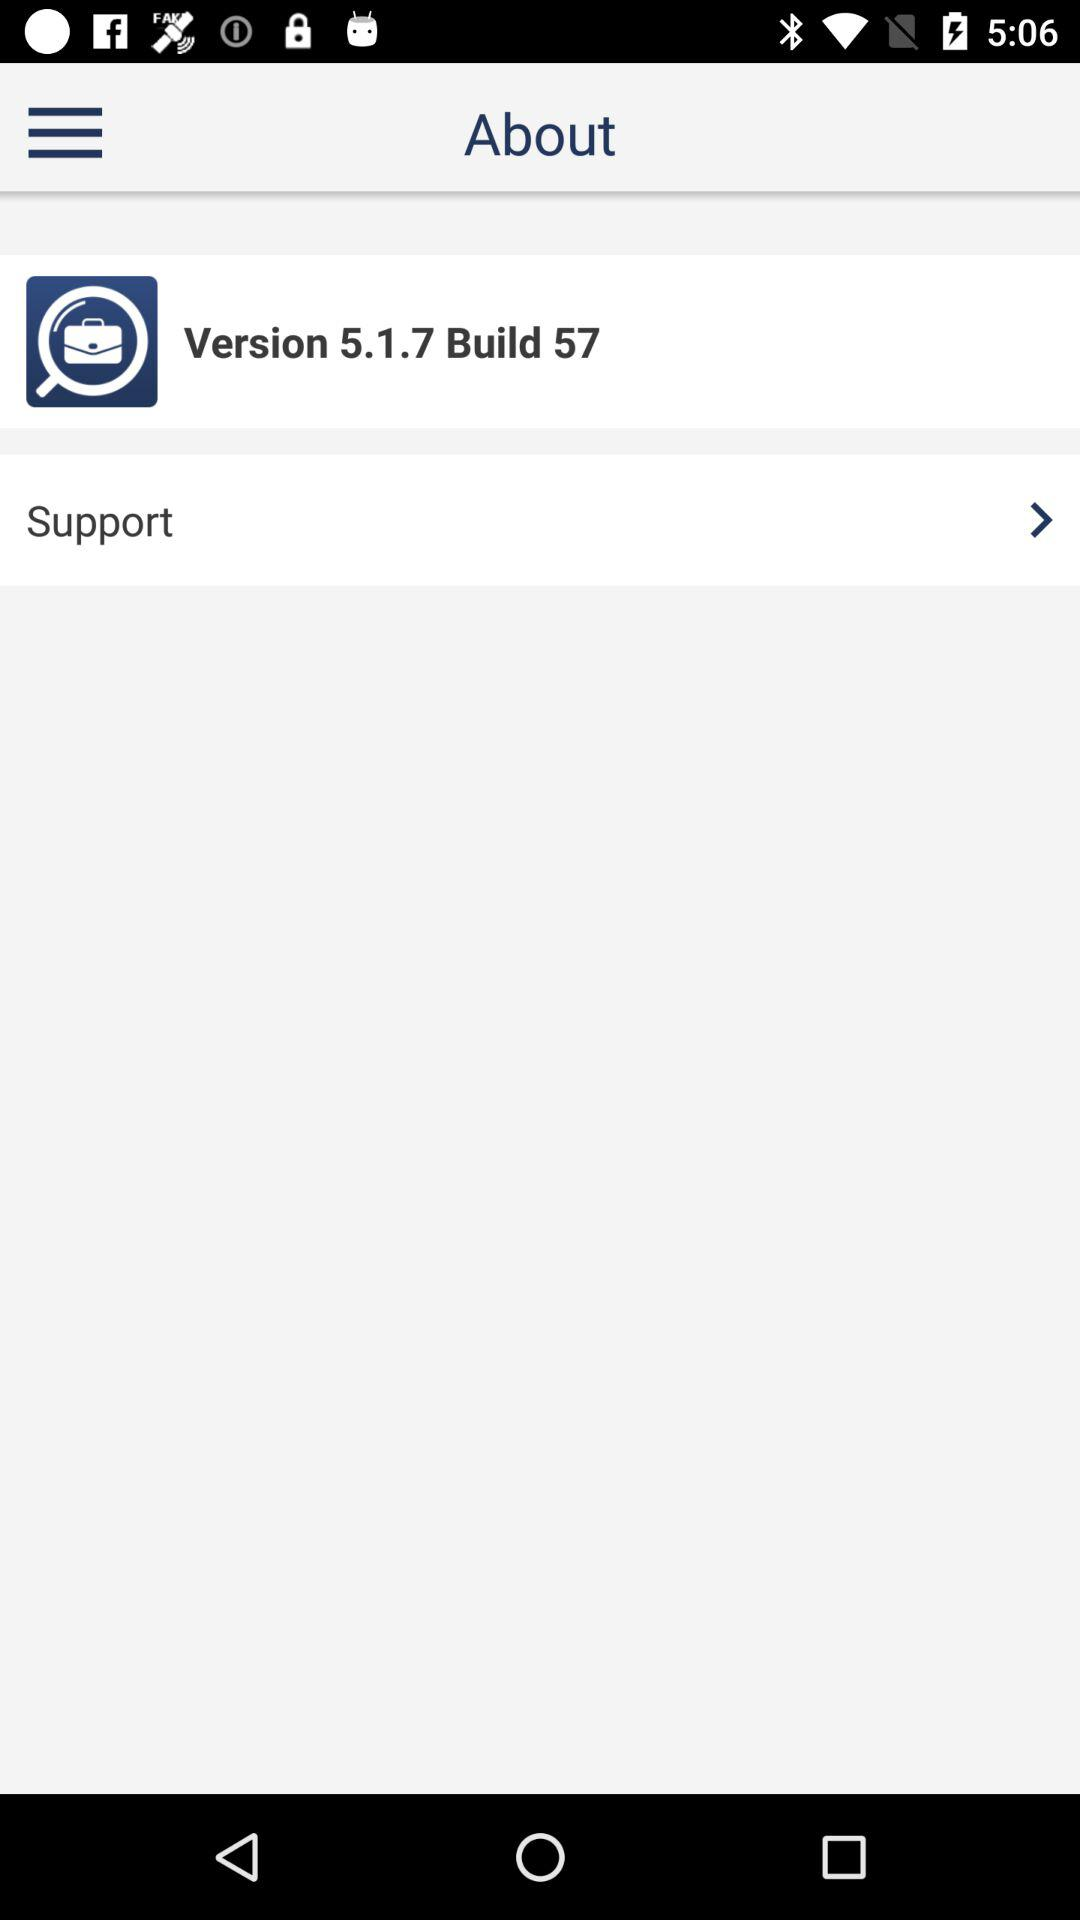What is build number? The build number is 57. 